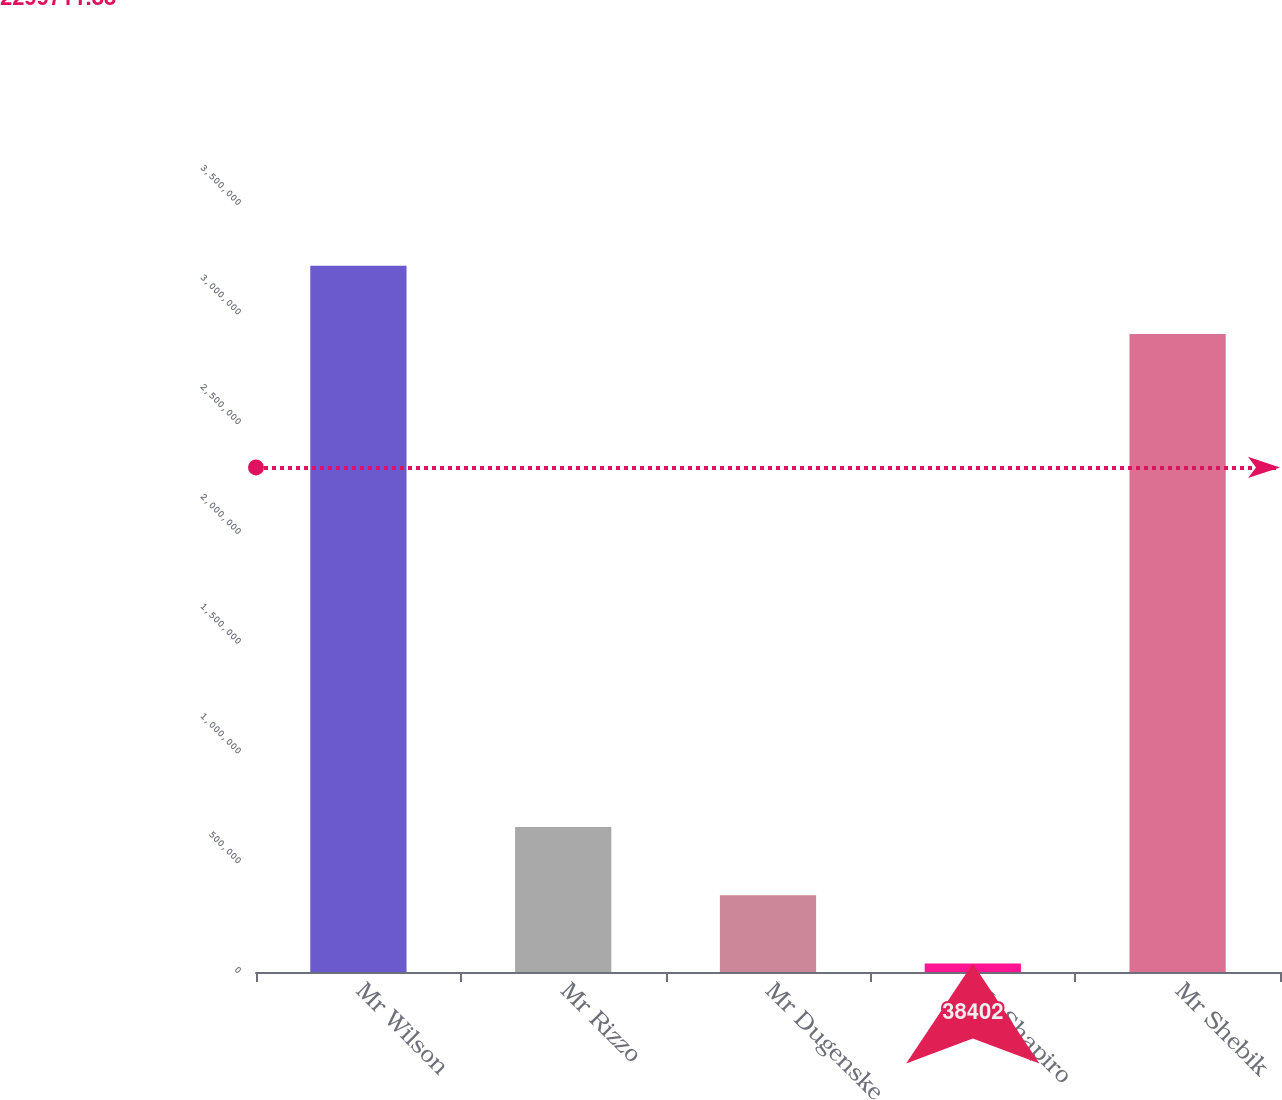<chart> <loc_0><loc_0><loc_500><loc_500><bar_chart><fcel>Mr Wilson<fcel>Mr Rizzo<fcel>Mr Dugenske<fcel>Mr Shapiro<fcel>Mr Shebik<nl><fcel>3.21852e+06<fcel>660877<fcel>349640<fcel>38402<fcel>2.90728e+06<nl></chart> 